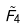<formula> <loc_0><loc_0><loc_500><loc_500>\tilde { F } _ { 4 }</formula> 